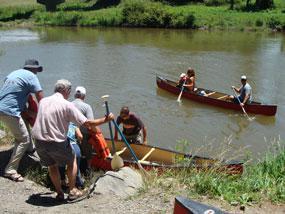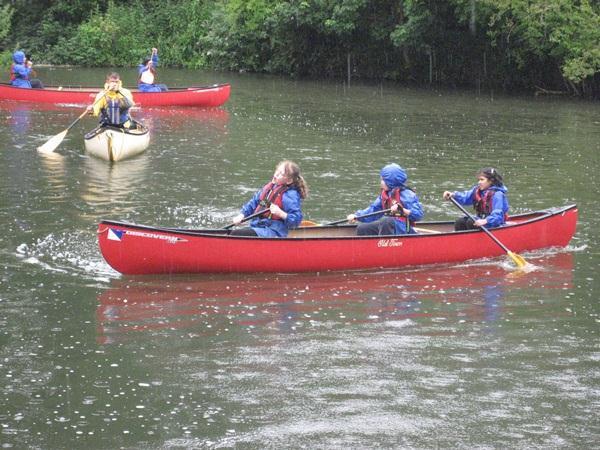The first image is the image on the left, the second image is the image on the right. Given the left and right images, does the statement "All the boats are in the water." hold true? Answer yes or no. No. The first image is the image on the left, the second image is the image on the right. Assess this claim about the two images: "The left image includes a person standing by an empty canoe that is pulled up to the water's edge, with at least one other canoe on the water in the background.". Correct or not? Answer yes or no. Yes. 